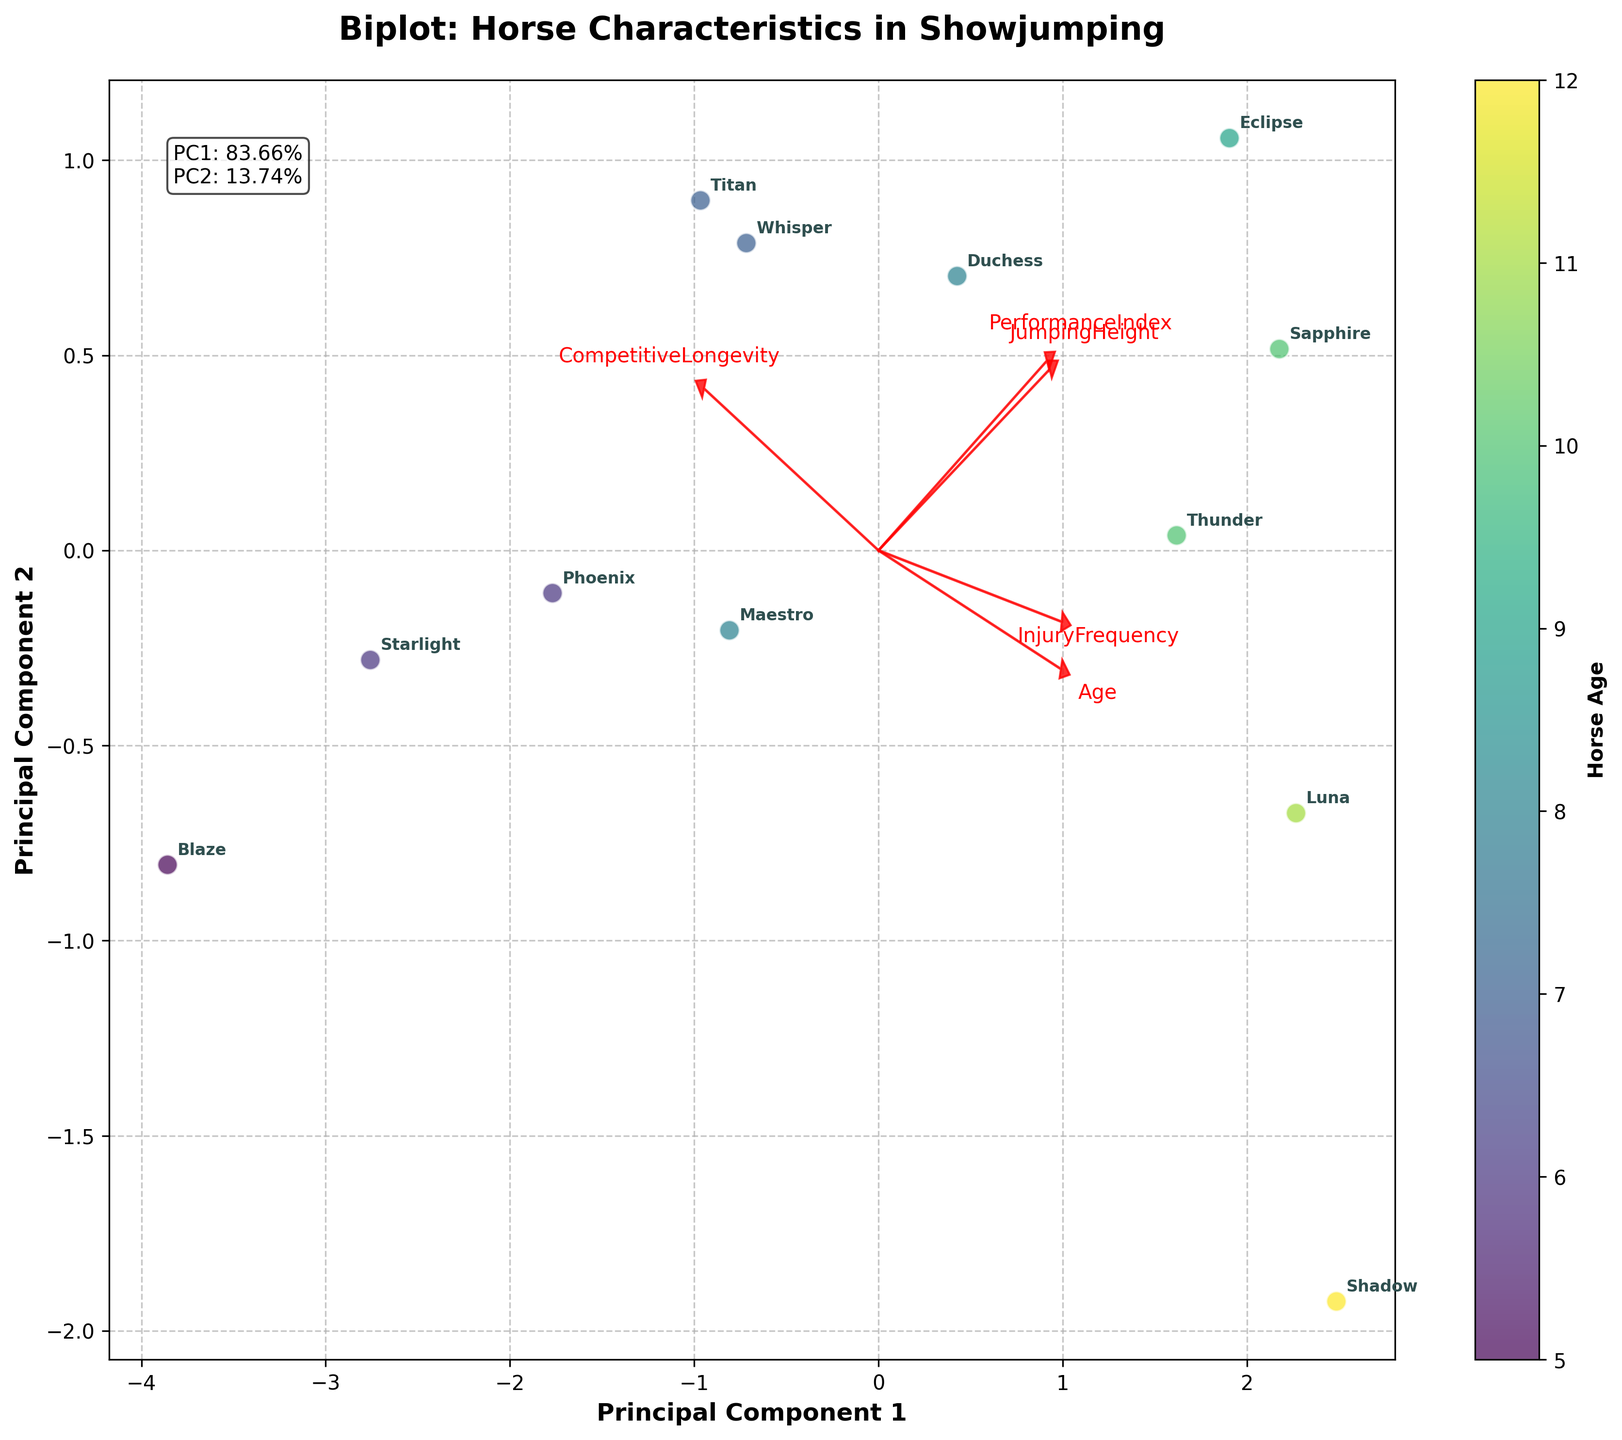What does the color of the points represent? The color of the points in the scatter plot represents the age of the horses, as indicated by the color bar on the right side of the plot labeled 'Horse Age'. Different colors correspond to different ages, with a gradient from younger to older horses.
Answer: Age of the horses How many principal components are used in this biplot? The plot shows two principal components on the axes, labeled 'Principal Component 1' and 'Principal Component 2'. This is indicated by the axis labels of the plot.
Answer: Two Which feature has the longest loading arrow in the biplot? 'PerformanceIndex' shows the longest arrow among the features. This can be observed by comparing the length of the red arrows labeled with each feature name.
Answer: PerformanceIndex Which horse has the highest competitive longevity according to the biplot? By observing the annotations for each point in the scatter plot, the horse named 'Blaze' is positioned towards the higher values on the PC1 axis, which relates to competitive longevity, indicating Blaze has the highest competitive longevity.
Answer: Blaze Can you identify a horse with high PerformanceIndex and low InjuryFrequency from the biplot? Titan demonstrates high PerformanceIndex, positioned closer to the arrow direction for 'PerformanceIndex', and lower InjuryFrequency as it is further from the 'InjuryFrequency' arrow. Annotation of Titan helps in locating the exact position.
Answer: Titan Which two horses appear closely clustered together in the biplot? Observing the positions of the annotated points, 'Maestro' and 'Duchess' appear closely clustered together in the biplot, indicating similarity in their overall characteristics.
Answer: Maestro and Duchess Are older or younger horses more scattered in the biplot? Based on the spread of the colored points from the color gradient, younger horses (e.g., colored in lighter shades) seem more dispersed compared to older horses, which are more concentrated.
Answer: Younger horses Is there a visible correlation between JumpingHeight and PerformanceIndex in the biplot? Both 'JumpingHeight' and 'PerformanceIndex' arrows point in directions close to each other, indicating some level of positive correlation between these two attributes. However, the exact strength of correlation is not provided in the plot.
Answer: Yes, likely positive What percentage of total variance is explained by Principal Component 1 and Principal Component 2? The text annotation on the plot indicates the explained variance: PC1 explains 47.12% and PC2 explains 23.45% of the total variance, summing these percentages provides the total variance explained by both components.
Answer: 70.57% 